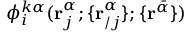<formula> <loc_0><loc_0><loc_500><loc_500>\phi _ { i } ^ { k \alpha } ( r _ { j } ^ { \alpha } ; \{ r _ { / j } ^ { \alpha } \} ; \{ r ^ { \bar { \alpha } } \} )</formula> 